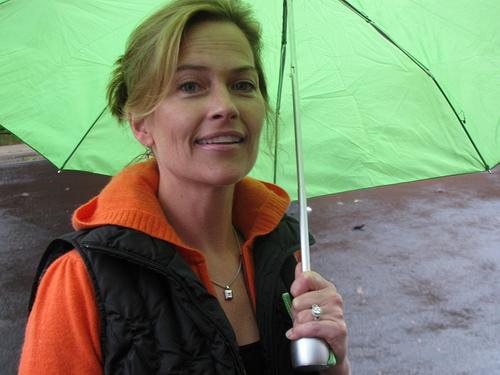Describe the appearance of the woman's eyes in the image. The woman has smiling blue eyes. State the color and functionality of the woman's sweater in the image. The woman is wearing an orange sweater with a hood. Describe the jewelry worn by the woman in the image. The woman is wearing a silver necklace with a square pendant, a large sparkling diamond ring on her finger, and an earring in her right ear. What is the weather condition as depicted in the picture? The weather condition seems to be rainy or just after a rain. What is the state of the road in the image and why does it appear that way? The road is wet and paved, likely due to recent rain. Provide a brief description of the scene in the image. A blonde woman wearing an orange sweater with a hood, a black padded vest, and a necklace is standing on a wet, paved street, holding a mint green umbrella. Identify the primary object the woman is holding. The woman is holding a mint green umbrella. List the colors and items of clothing that the woman is wearing in the image. The woman is wearing an orange sweater with a hood, a black padded vest, and a necklace with a square pendant. What is the hair color of the lady in the image? The lady has blonde hair. Mention the color and type of overcoat worn by the woman in the image. The woman is wearing a black padded vest. 